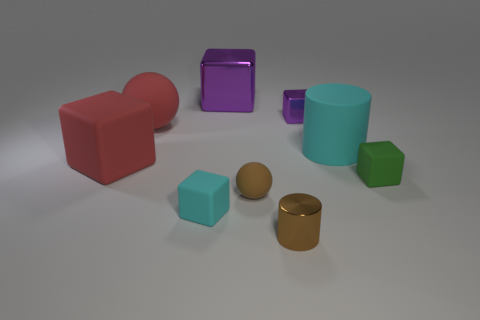Do the large rubber object on the right side of the tiny purple object and the small cylinder have the same color?
Your answer should be compact. No. How many brown things are rubber objects or spheres?
Offer a very short reply. 1. How many other objects are the same shape as the tiny cyan rubber thing?
Give a very brief answer. 4. Does the brown cylinder have the same material as the big red cube?
Your response must be concise. No. What is the material of the thing that is both behind the large cylinder and in front of the tiny purple metallic block?
Provide a succinct answer. Rubber. What is the color of the small rubber block right of the big rubber cylinder?
Your answer should be compact. Green. Is the number of tiny rubber balls behind the red rubber cube greater than the number of brown spheres?
Offer a very short reply. No. How many other objects are the same size as the cyan matte cylinder?
Provide a succinct answer. 3. There is a large red rubber block; how many purple shiny things are in front of it?
Give a very brief answer. 0. Are there the same number of cyan things that are behind the big red cube and cyan cubes that are behind the big cylinder?
Offer a terse response. No. 